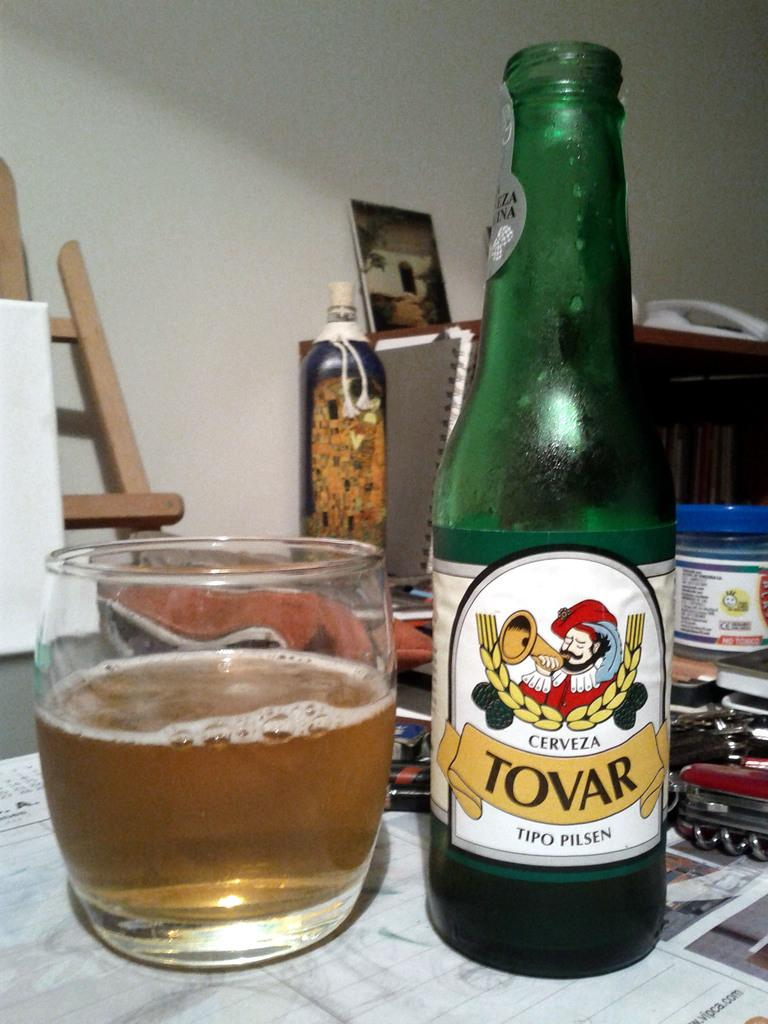<image>
Write a terse but informative summary of the picture. Tovar beer bottle next to a small cup of beer. 